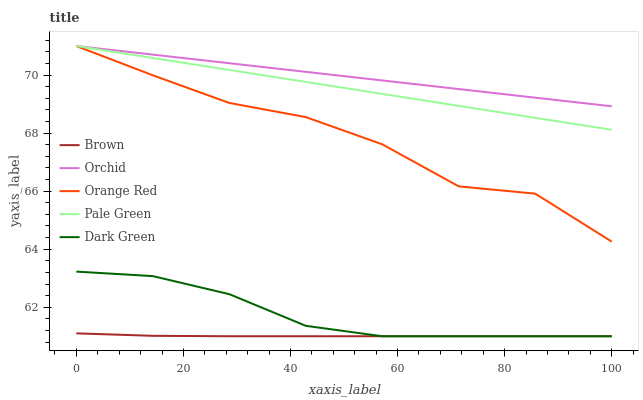Does Brown have the minimum area under the curve?
Answer yes or no. Yes. Does Orchid have the maximum area under the curve?
Answer yes or no. Yes. Does Pale Green have the minimum area under the curve?
Answer yes or no. No. Does Pale Green have the maximum area under the curve?
Answer yes or no. No. Is Orchid the smoothest?
Answer yes or no. Yes. Is Orange Red the roughest?
Answer yes or no. Yes. Is Brown the smoothest?
Answer yes or no. No. Is Brown the roughest?
Answer yes or no. No. Does Dark Green have the lowest value?
Answer yes or no. Yes. Does Pale Green have the lowest value?
Answer yes or no. No. Does Orchid have the highest value?
Answer yes or no. Yes. Does Brown have the highest value?
Answer yes or no. No. Is Dark Green less than Orange Red?
Answer yes or no. Yes. Is Orange Red greater than Dark Green?
Answer yes or no. Yes. Does Dark Green intersect Brown?
Answer yes or no. Yes. Is Dark Green less than Brown?
Answer yes or no. No. Is Dark Green greater than Brown?
Answer yes or no. No. Does Dark Green intersect Orange Red?
Answer yes or no. No. 